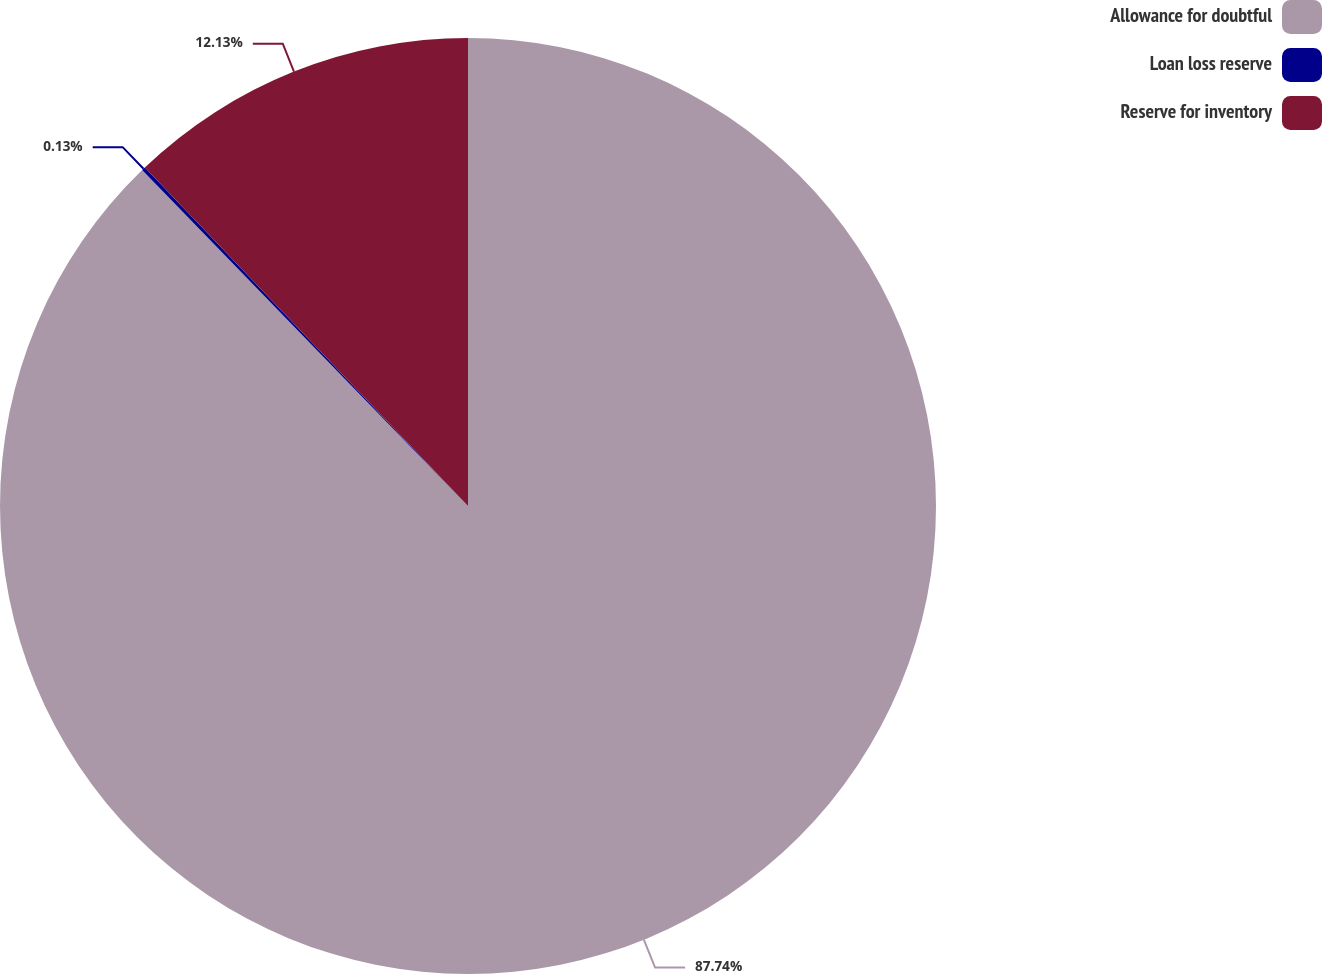Convert chart. <chart><loc_0><loc_0><loc_500><loc_500><pie_chart><fcel>Allowance for doubtful<fcel>Loan loss reserve<fcel>Reserve for inventory<nl><fcel>87.74%<fcel>0.13%<fcel>12.13%<nl></chart> 